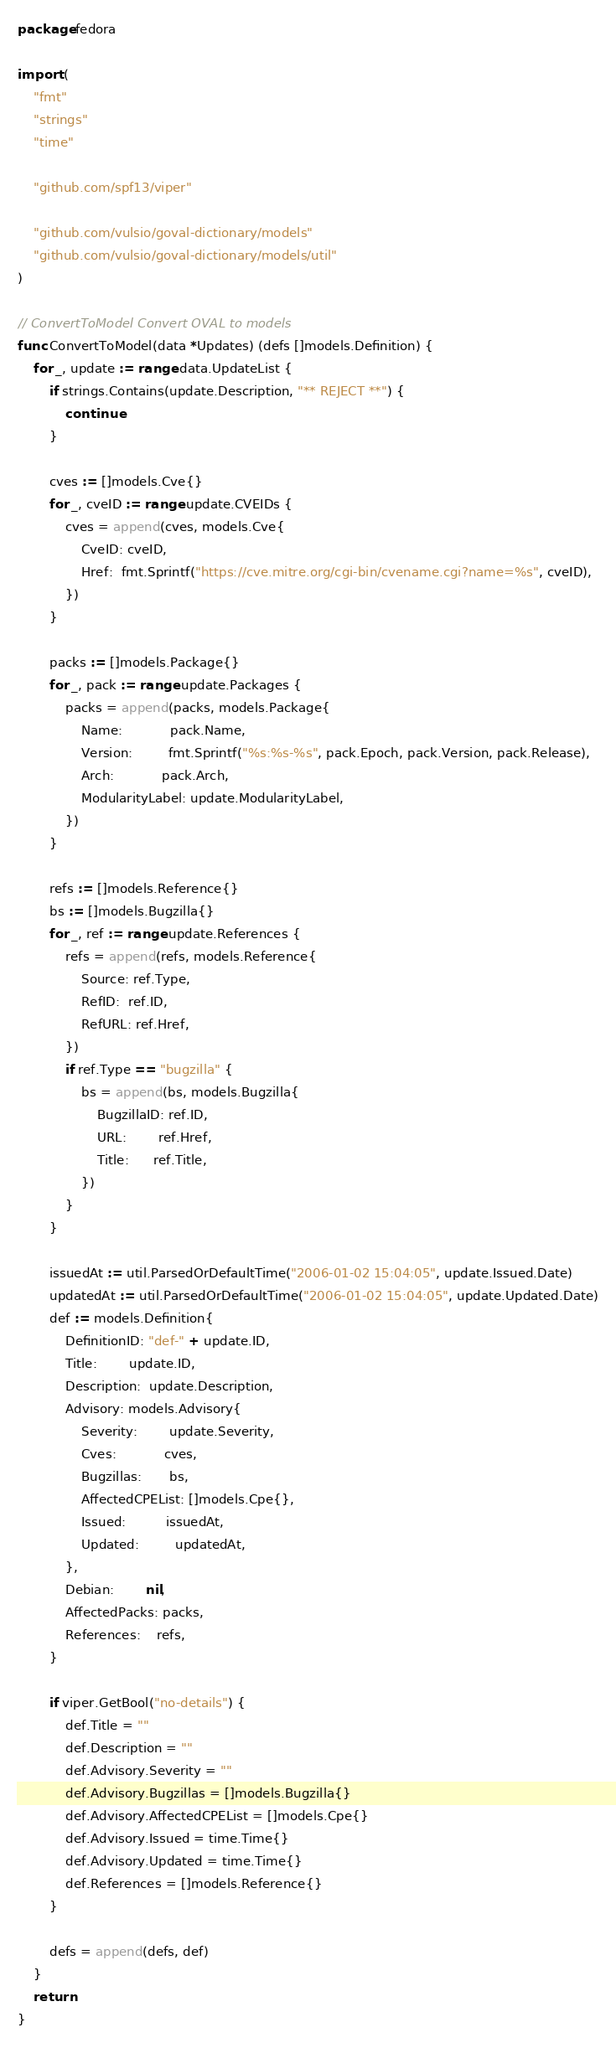<code> <loc_0><loc_0><loc_500><loc_500><_Go_>package fedora

import (
	"fmt"
	"strings"
	"time"

	"github.com/spf13/viper"

	"github.com/vulsio/goval-dictionary/models"
	"github.com/vulsio/goval-dictionary/models/util"
)

// ConvertToModel Convert OVAL to models
func ConvertToModel(data *Updates) (defs []models.Definition) {
	for _, update := range data.UpdateList {
		if strings.Contains(update.Description, "** REJECT **") {
			continue
		}

		cves := []models.Cve{}
		for _, cveID := range update.CVEIDs {
			cves = append(cves, models.Cve{
				CveID: cveID,
				Href:  fmt.Sprintf("https://cve.mitre.org/cgi-bin/cvename.cgi?name=%s", cveID),
			})
		}

		packs := []models.Package{}
		for _, pack := range update.Packages {
			packs = append(packs, models.Package{
				Name:            pack.Name,
				Version:         fmt.Sprintf("%s:%s-%s", pack.Epoch, pack.Version, pack.Release),
				Arch:            pack.Arch,
				ModularityLabel: update.ModularityLabel,
			})
		}

		refs := []models.Reference{}
		bs := []models.Bugzilla{}
		for _, ref := range update.References {
			refs = append(refs, models.Reference{
				Source: ref.Type,
				RefID:  ref.ID,
				RefURL: ref.Href,
			})
			if ref.Type == "bugzilla" {
				bs = append(bs, models.Bugzilla{
					BugzillaID: ref.ID,
					URL:        ref.Href,
					Title:      ref.Title,
				})
			}
		}

		issuedAt := util.ParsedOrDefaultTime("2006-01-02 15:04:05", update.Issued.Date)
		updatedAt := util.ParsedOrDefaultTime("2006-01-02 15:04:05", update.Updated.Date)
		def := models.Definition{
			DefinitionID: "def-" + update.ID,
			Title:        update.ID,
			Description:  update.Description,
			Advisory: models.Advisory{
				Severity:        update.Severity,
				Cves:            cves,
				Bugzillas:       bs,
				AffectedCPEList: []models.Cpe{},
				Issued:          issuedAt,
				Updated:         updatedAt,
			},
			Debian:        nil,
			AffectedPacks: packs,
			References:    refs,
		}

		if viper.GetBool("no-details") {
			def.Title = ""
			def.Description = ""
			def.Advisory.Severity = ""
			def.Advisory.Bugzillas = []models.Bugzilla{}
			def.Advisory.AffectedCPEList = []models.Cpe{}
			def.Advisory.Issued = time.Time{}
			def.Advisory.Updated = time.Time{}
			def.References = []models.Reference{}
		}

		defs = append(defs, def)
	}
	return
}
</code> 